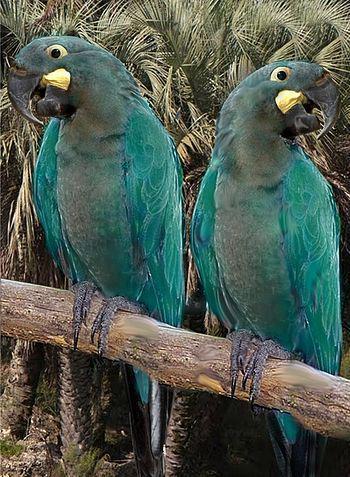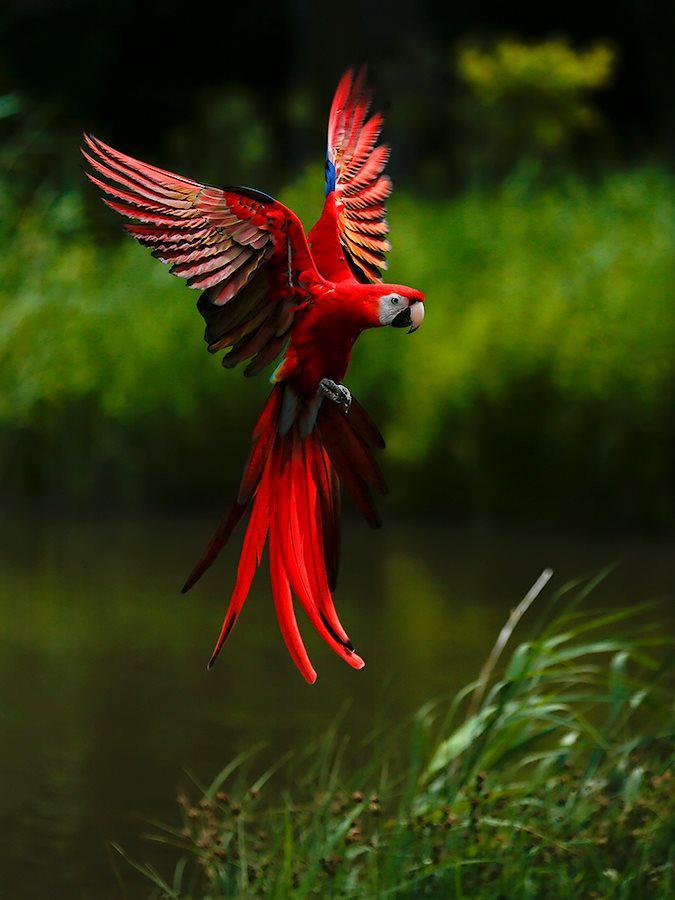The first image is the image on the left, the second image is the image on the right. For the images displayed, is the sentence "In one image, two teal colored parrots are sitting together on a tree branch." factually correct? Answer yes or no. Yes. The first image is the image on the left, the second image is the image on the right. Given the left and right images, does the statement "A total of three parrots are depicted in the images." hold true? Answer yes or no. Yes. 